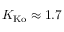<formula> <loc_0><loc_0><loc_500><loc_500>K _ { K o } \approx 1 . 7</formula> 